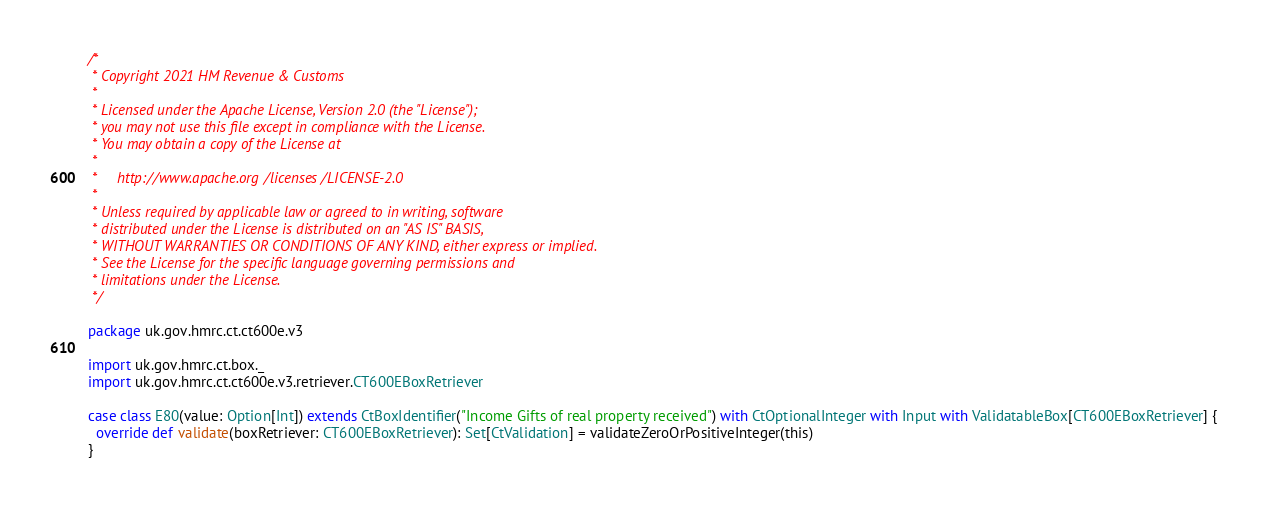Convert code to text. <code><loc_0><loc_0><loc_500><loc_500><_Scala_>/*
 * Copyright 2021 HM Revenue & Customs
 *
 * Licensed under the Apache License, Version 2.0 (the "License");
 * you may not use this file except in compliance with the License.
 * You may obtain a copy of the License at
 *
 *     http://www.apache.org/licenses/LICENSE-2.0
 *
 * Unless required by applicable law or agreed to in writing, software
 * distributed under the License is distributed on an "AS IS" BASIS,
 * WITHOUT WARRANTIES OR CONDITIONS OF ANY KIND, either express or implied.
 * See the License for the specific language governing permissions and
 * limitations under the License.
 */

package uk.gov.hmrc.ct.ct600e.v3

import uk.gov.hmrc.ct.box._
import uk.gov.hmrc.ct.ct600e.v3.retriever.CT600EBoxRetriever

case class E80(value: Option[Int]) extends CtBoxIdentifier("Income Gifts of real property received") with CtOptionalInteger with Input with ValidatableBox[CT600EBoxRetriever] {
  override def validate(boxRetriever: CT600EBoxRetriever): Set[CtValidation] = validateZeroOrPositiveInteger(this)
}
</code> 